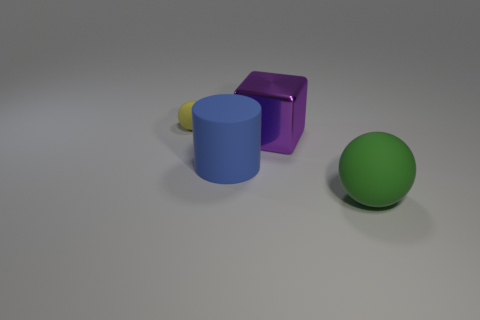Add 1 tiny yellow rubber things. How many objects exist? 5 Subtract all blocks. How many objects are left? 3 Add 4 yellow matte spheres. How many yellow matte spheres exist? 5 Subtract 0 yellow cylinders. How many objects are left? 4 Subtract all blue objects. Subtract all rubber spheres. How many objects are left? 1 Add 3 big green spheres. How many big green spheres are left? 4 